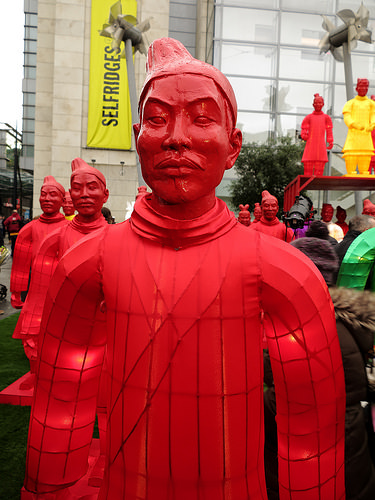<image>
Is the hat on the person? No. The hat is not positioned on the person. They may be near each other, but the hat is not supported by or resting on top of the person. 